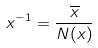<formula> <loc_0><loc_0><loc_500><loc_500>x ^ { - 1 } = \frac { \overline { x } } { N ( x ) }</formula> 